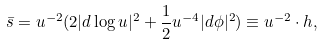Convert formula to latex. <formula><loc_0><loc_0><loc_500><loc_500>\bar { s } = u ^ { - 2 } ( 2 | d \log u | ^ { 2 } + \frac { 1 } { 2 } u ^ { - 4 } | d \phi | ^ { 2 } ) \equiv u ^ { - 2 } \cdot h ,</formula> 